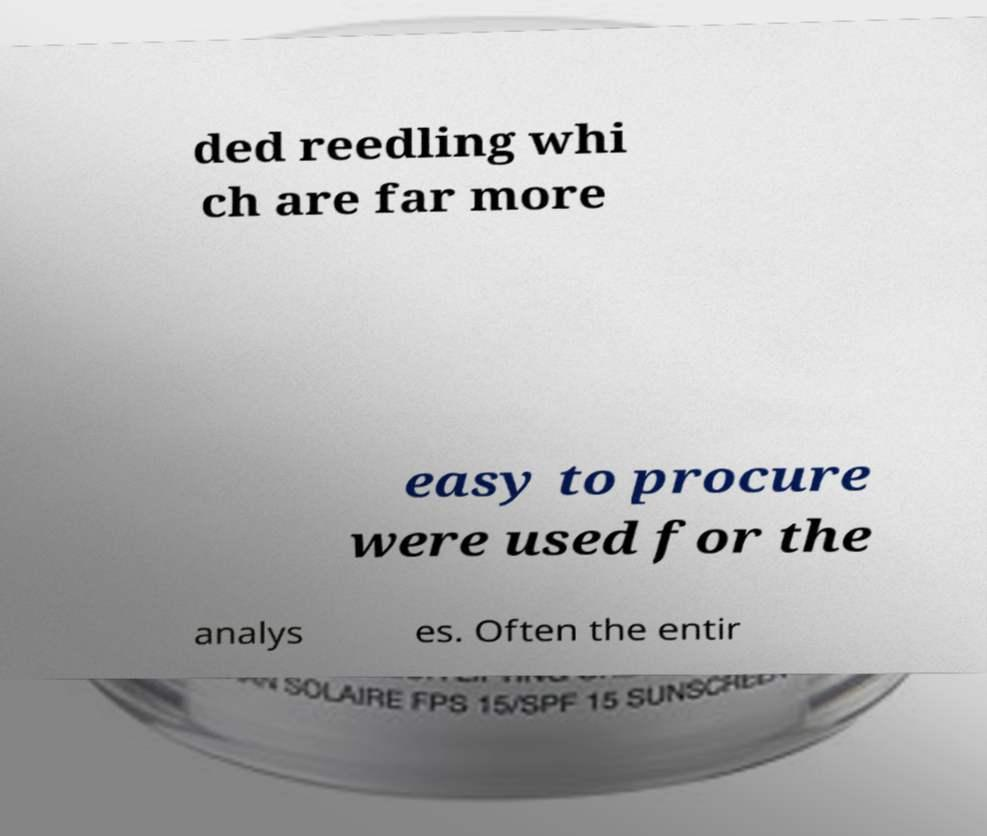For documentation purposes, I need the text within this image transcribed. Could you provide that? ded reedling whi ch are far more easy to procure were used for the analys es. Often the entir 